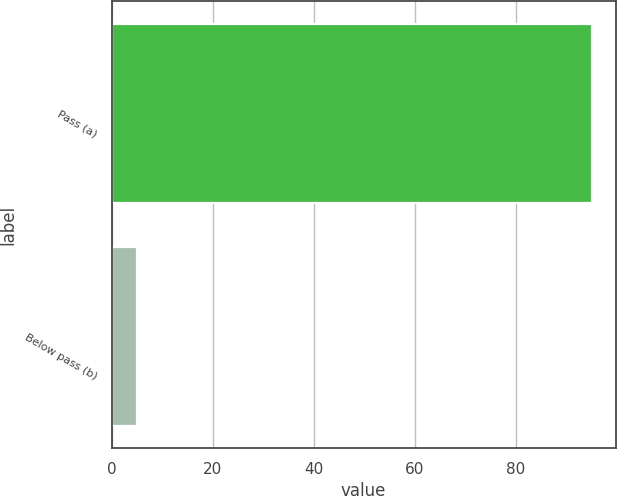<chart> <loc_0><loc_0><loc_500><loc_500><bar_chart><fcel>Pass (a)<fcel>Below pass (b)<nl><fcel>95<fcel>5<nl></chart> 